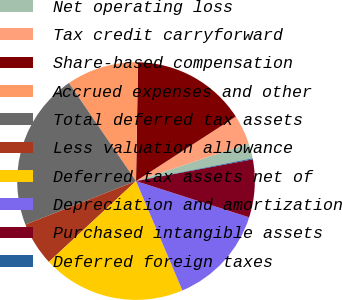Convert chart. <chart><loc_0><loc_0><loc_500><loc_500><pie_chart><fcel>Net operating loss<fcel>Tax credit carryforward<fcel>Share-based compensation<fcel>Accrued expenses and other<fcel>Total deferred tax assets<fcel>Less valuation allowance<fcel>Deferred tax assets net of<fcel>Depreciation and amortization<fcel>Purchased intangible assets<fcel>Deferred foreign taxes<nl><fcel>2.07%<fcel>4.0%<fcel>15.61%<fcel>9.81%<fcel>21.42%<fcel>5.94%<fcel>19.48%<fcel>13.68%<fcel>7.87%<fcel>0.13%<nl></chart> 